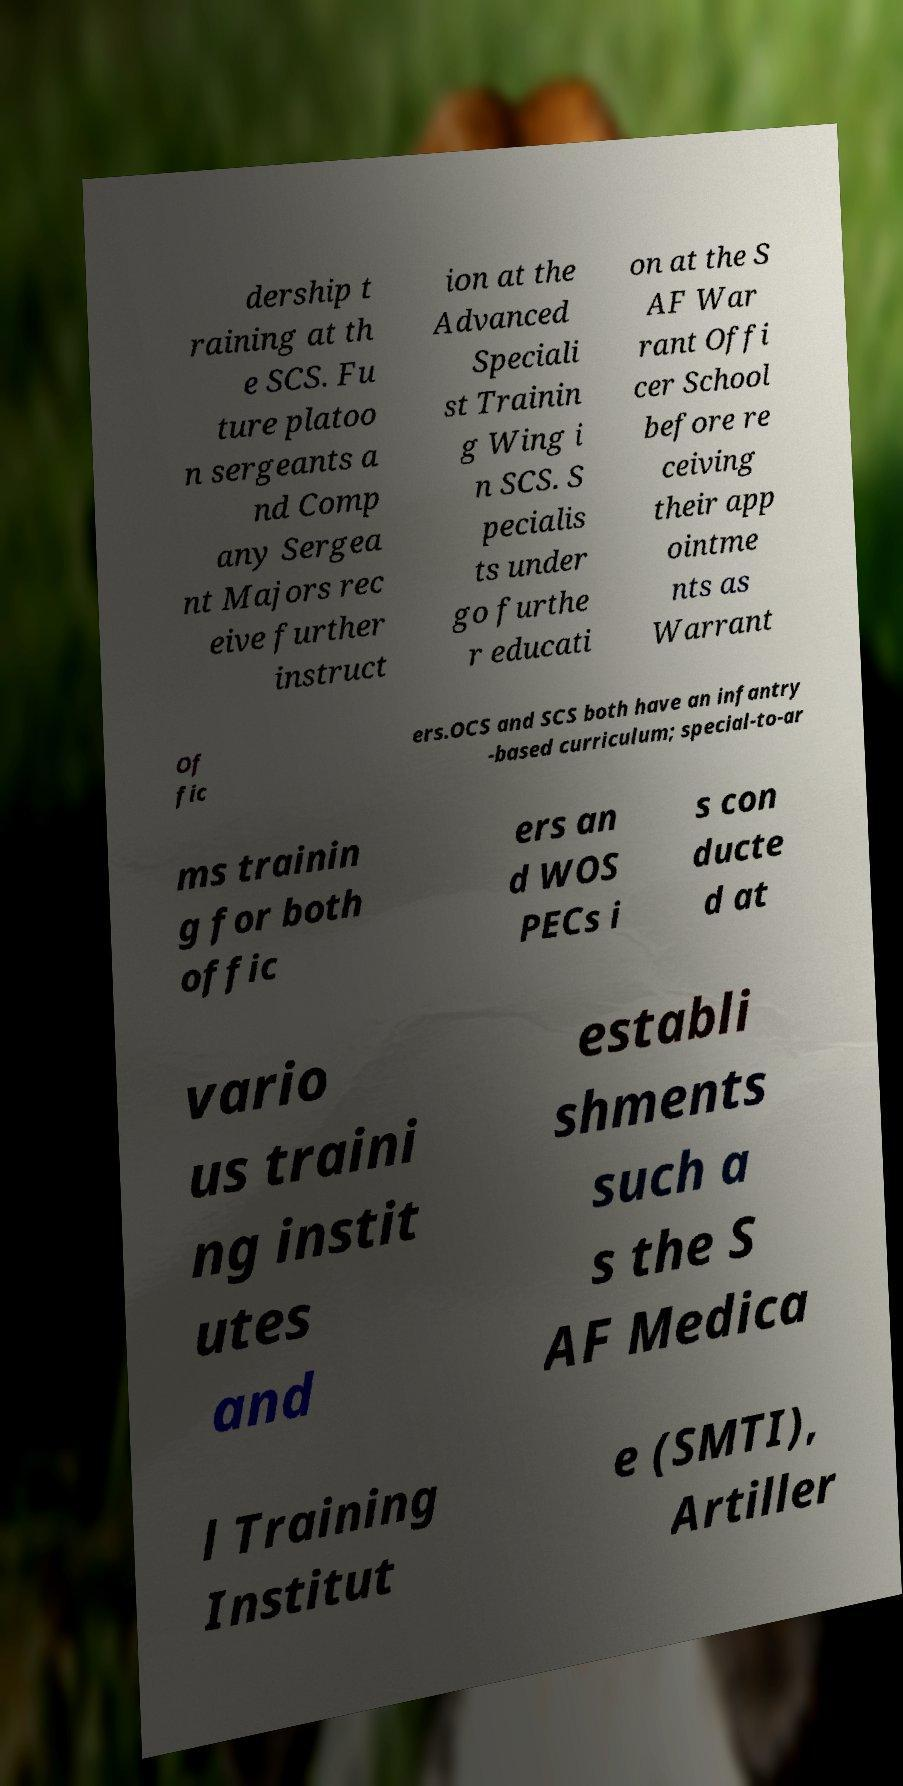There's text embedded in this image that I need extracted. Can you transcribe it verbatim? dership t raining at th e SCS. Fu ture platoo n sergeants a nd Comp any Sergea nt Majors rec eive further instruct ion at the Advanced Speciali st Trainin g Wing i n SCS. S pecialis ts under go furthe r educati on at the S AF War rant Offi cer School before re ceiving their app ointme nts as Warrant Of fic ers.OCS and SCS both have an infantry -based curriculum; special-to-ar ms trainin g for both offic ers an d WOS PECs i s con ducte d at vario us traini ng instit utes and establi shments such a s the S AF Medica l Training Institut e (SMTI), Artiller 